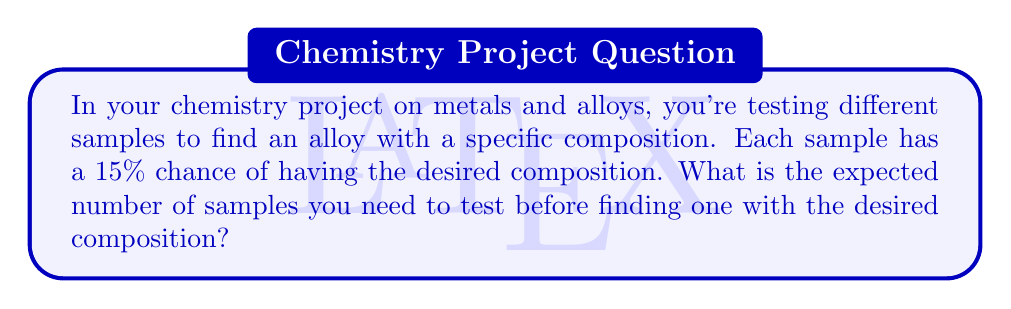Could you help me with this problem? Let's approach this step-by-step:

1) This scenario follows a geometric distribution. The geometric distribution models the number of trials needed to achieve the first success in a series of independent Bernoulli trials.

2) In a geometric distribution, the expected value (mean) is given by the formula:

   $$E(X) = \frac{1}{p}$$

   where $p$ is the probability of success on each trial.

3) In this case, $p = 0.15$ or 15%, as each sample has a 15% chance of having the desired composition.

4) Plugging this into our formula:

   $$E(X) = \frac{1}{0.15}$$

5) Calculating this:

   $$E(X) = 6.67$$

6) Since we can't test a fractional number of samples, we round up to the nearest whole number.

Therefore, you can expect to test 7 samples on average before finding one with the desired composition.
Answer: The expected number of samples needed is 7. 